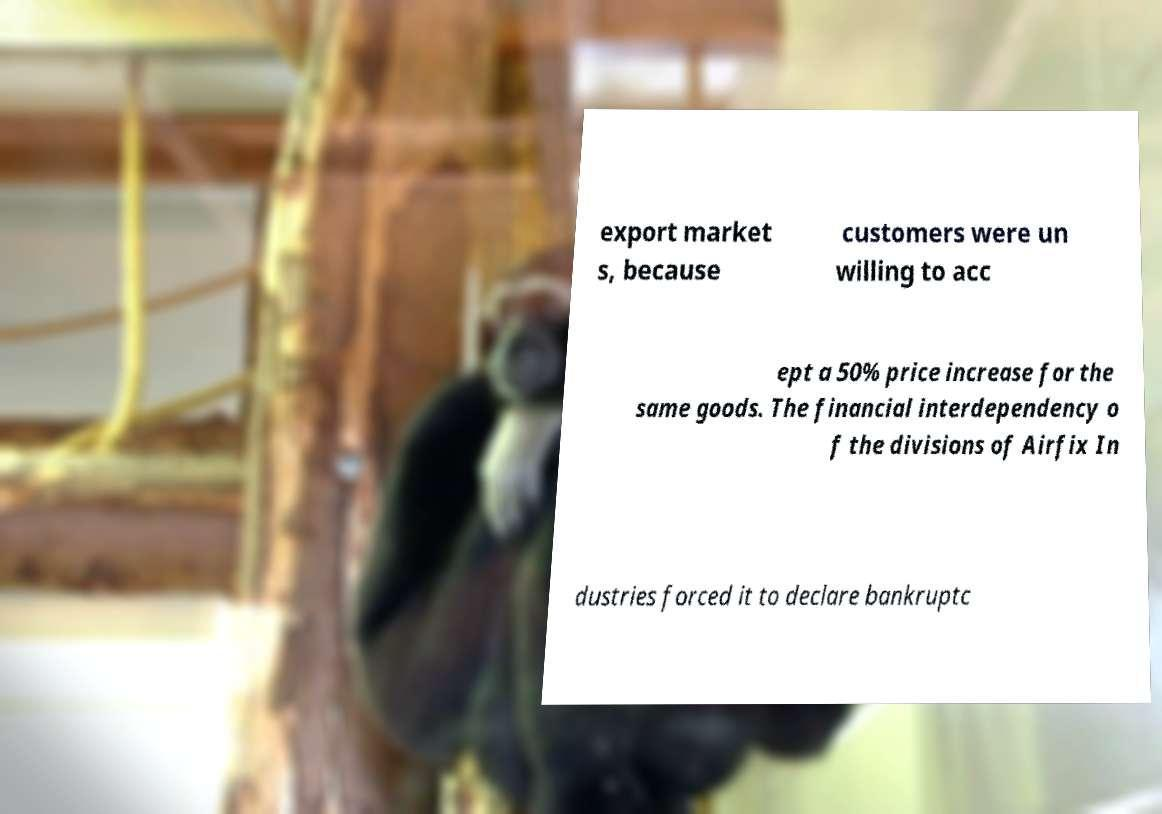There's text embedded in this image that I need extracted. Can you transcribe it verbatim? export market s, because customers were un willing to acc ept a 50% price increase for the same goods. The financial interdependency o f the divisions of Airfix In dustries forced it to declare bankruptc 